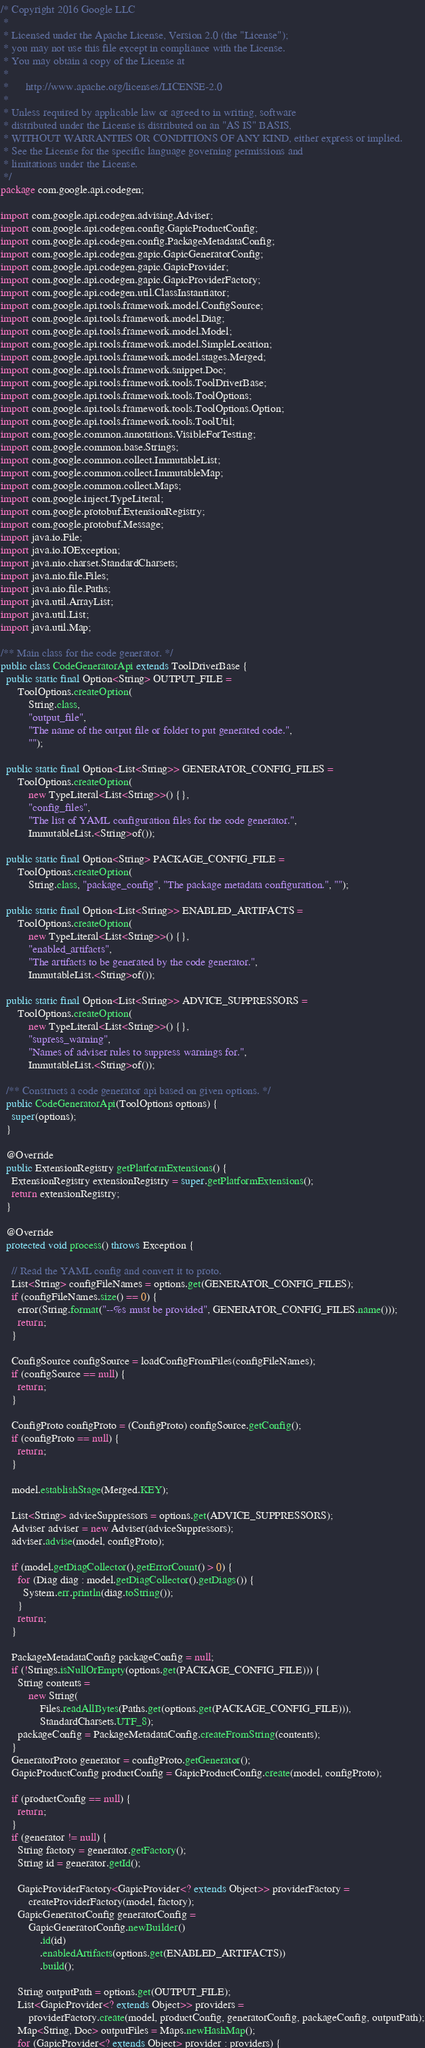Convert code to text. <code><loc_0><loc_0><loc_500><loc_500><_Java_>/* Copyright 2016 Google LLC
 *
 * Licensed under the Apache License, Version 2.0 (the "License");
 * you may not use this file except in compliance with the License.
 * You may obtain a copy of the License at
 *
 *      http://www.apache.org/licenses/LICENSE-2.0
 *
 * Unless required by applicable law or agreed to in writing, software
 * distributed under the License is distributed on an "AS IS" BASIS,
 * WITHOUT WARRANTIES OR CONDITIONS OF ANY KIND, either express or implied.
 * See the License for the specific language governing permissions and
 * limitations under the License.
 */
package com.google.api.codegen;

import com.google.api.codegen.advising.Adviser;
import com.google.api.codegen.config.GapicProductConfig;
import com.google.api.codegen.config.PackageMetadataConfig;
import com.google.api.codegen.gapic.GapicGeneratorConfig;
import com.google.api.codegen.gapic.GapicProvider;
import com.google.api.codegen.gapic.GapicProviderFactory;
import com.google.api.codegen.util.ClassInstantiator;
import com.google.api.tools.framework.model.ConfigSource;
import com.google.api.tools.framework.model.Diag;
import com.google.api.tools.framework.model.Model;
import com.google.api.tools.framework.model.SimpleLocation;
import com.google.api.tools.framework.model.stages.Merged;
import com.google.api.tools.framework.snippet.Doc;
import com.google.api.tools.framework.tools.ToolDriverBase;
import com.google.api.tools.framework.tools.ToolOptions;
import com.google.api.tools.framework.tools.ToolOptions.Option;
import com.google.api.tools.framework.tools.ToolUtil;
import com.google.common.annotations.VisibleForTesting;
import com.google.common.base.Strings;
import com.google.common.collect.ImmutableList;
import com.google.common.collect.ImmutableMap;
import com.google.common.collect.Maps;
import com.google.inject.TypeLiteral;
import com.google.protobuf.ExtensionRegistry;
import com.google.protobuf.Message;
import java.io.File;
import java.io.IOException;
import java.nio.charset.StandardCharsets;
import java.nio.file.Files;
import java.nio.file.Paths;
import java.util.ArrayList;
import java.util.List;
import java.util.Map;

/** Main class for the code generator. */
public class CodeGeneratorApi extends ToolDriverBase {
  public static final Option<String> OUTPUT_FILE =
      ToolOptions.createOption(
          String.class,
          "output_file",
          "The name of the output file or folder to put generated code.",
          "");

  public static final Option<List<String>> GENERATOR_CONFIG_FILES =
      ToolOptions.createOption(
          new TypeLiteral<List<String>>() {},
          "config_files",
          "The list of YAML configuration files for the code generator.",
          ImmutableList.<String>of());

  public static final Option<String> PACKAGE_CONFIG_FILE =
      ToolOptions.createOption(
          String.class, "package_config", "The package metadata configuration.", "");

  public static final Option<List<String>> ENABLED_ARTIFACTS =
      ToolOptions.createOption(
          new TypeLiteral<List<String>>() {},
          "enabled_artifacts",
          "The artifacts to be generated by the code generator.",
          ImmutableList.<String>of());

  public static final Option<List<String>> ADVICE_SUPPRESSORS =
      ToolOptions.createOption(
          new TypeLiteral<List<String>>() {},
          "supress_warning",
          "Names of adviser rules to suppress warnings for.",
          ImmutableList.<String>of());

  /** Constructs a code generator api based on given options. */
  public CodeGeneratorApi(ToolOptions options) {
    super(options);
  }

  @Override
  public ExtensionRegistry getPlatformExtensions() {
    ExtensionRegistry extensionRegistry = super.getPlatformExtensions();
    return extensionRegistry;
  }

  @Override
  protected void process() throws Exception {

    // Read the YAML config and convert it to proto.
    List<String> configFileNames = options.get(GENERATOR_CONFIG_FILES);
    if (configFileNames.size() == 0) {
      error(String.format("--%s must be provided", GENERATOR_CONFIG_FILES.name()));
      return;
    }

    ConfigSource configSource = loadConfigFromFiles(configFileNames);
    if (configSource == null) {
      return;
    }

    ConfigProto configProto = (ConfigProto) configSource.getConfig();
    if (configProto == null) {
      return;
    }

    model.establishStage(Merged.KEY);

    List<String> adviceSuppressors = options.get(ADVICE_SUPPRESSORS);
    Adviser adviser = new Adviser(adviceSuppressors);
    adviser.advise(model, configProto);

    if (model.getDiagCollector().getErrorCount() > 0) {
      for (Diag diag : model.getDiagCollector().getDiags()) {
        System.err.println(diag.toString());
      }
      return;
    }

    PackageMetadataConfig packageConfig = null;
    if (!Strings.isNullOrEmpty(options.get(PACKAGE_CONFIG_FILE))) {
      String contents =
          new String(
              Files.readAllBytes(Paths.get(options.get(PACKAGE_CONFIG_FILE))),
              StandardCharsets.UTF_8);
      packageConfig = PackageMetadataConfig.createFromString(contents);
    }
    GeneratorProto generator = configProto.getGenerator();
    GapicProductConfig productConfig = GapicProductConfig.create(model, configProto);

    if (productConfig == null) {
      return;
    }
    if (generator != null) {
      String factory = generator.getFactory();
      String id = generator.getId();

      GapicProviderFactory<GapicProvider<? extends Object>> providerFactory =
          createProviderFactory(model, factory);
      GapicGeneratorConfig generatorConfig =
          GapicGeneratorConfig.newBuilder()
              .id(id)
              .enabledArtifacts(options.get(ENABLED_ARTIFACTS))
              .build();

      String outputPath = options.get(OUTPUT_FILE);
      List<GapicProvider<? extends Object>> providers =
          providerFactory.create(model, productConfig, generatorConfig, packageConfig, outputPath);
      Map<String, Doc> outputFiles = Maps.newHashMap();
      for (GapicProvider<? extends Object> provider : providers) {</code> 